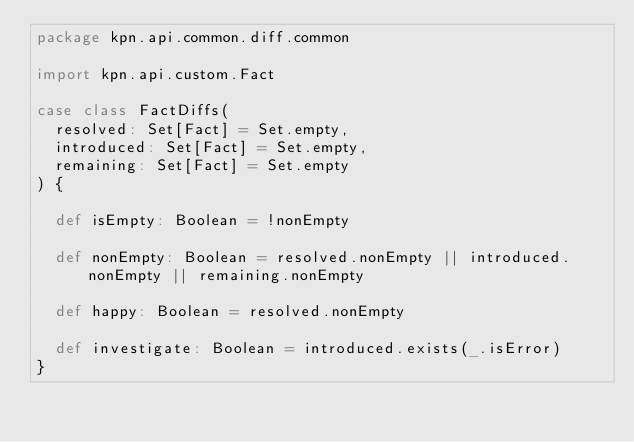<code> <loc_0><loc_0><loc_500><loc_500><_Scala_>package kpn.api.common.diff.common

import kpn.api.custom.Fact

case class FactDiffs(
  resolved: Set[Fact] = Set.empty,
  introduced: Set[Fact] = Set.empty,
  remaining: Set[Fact] = Set.empty
) {

  def isEmpty: Boolean = !nonEmpty

  def nonEmpty: Boolean = resolved.nonEmpty || introduced.nonEmpty || remaining.nonEmpty

  def happy: Boolean = resolved.nonEmpty

  def investigate: Boolean = introduced.exists(_.isError)
}
</code> 